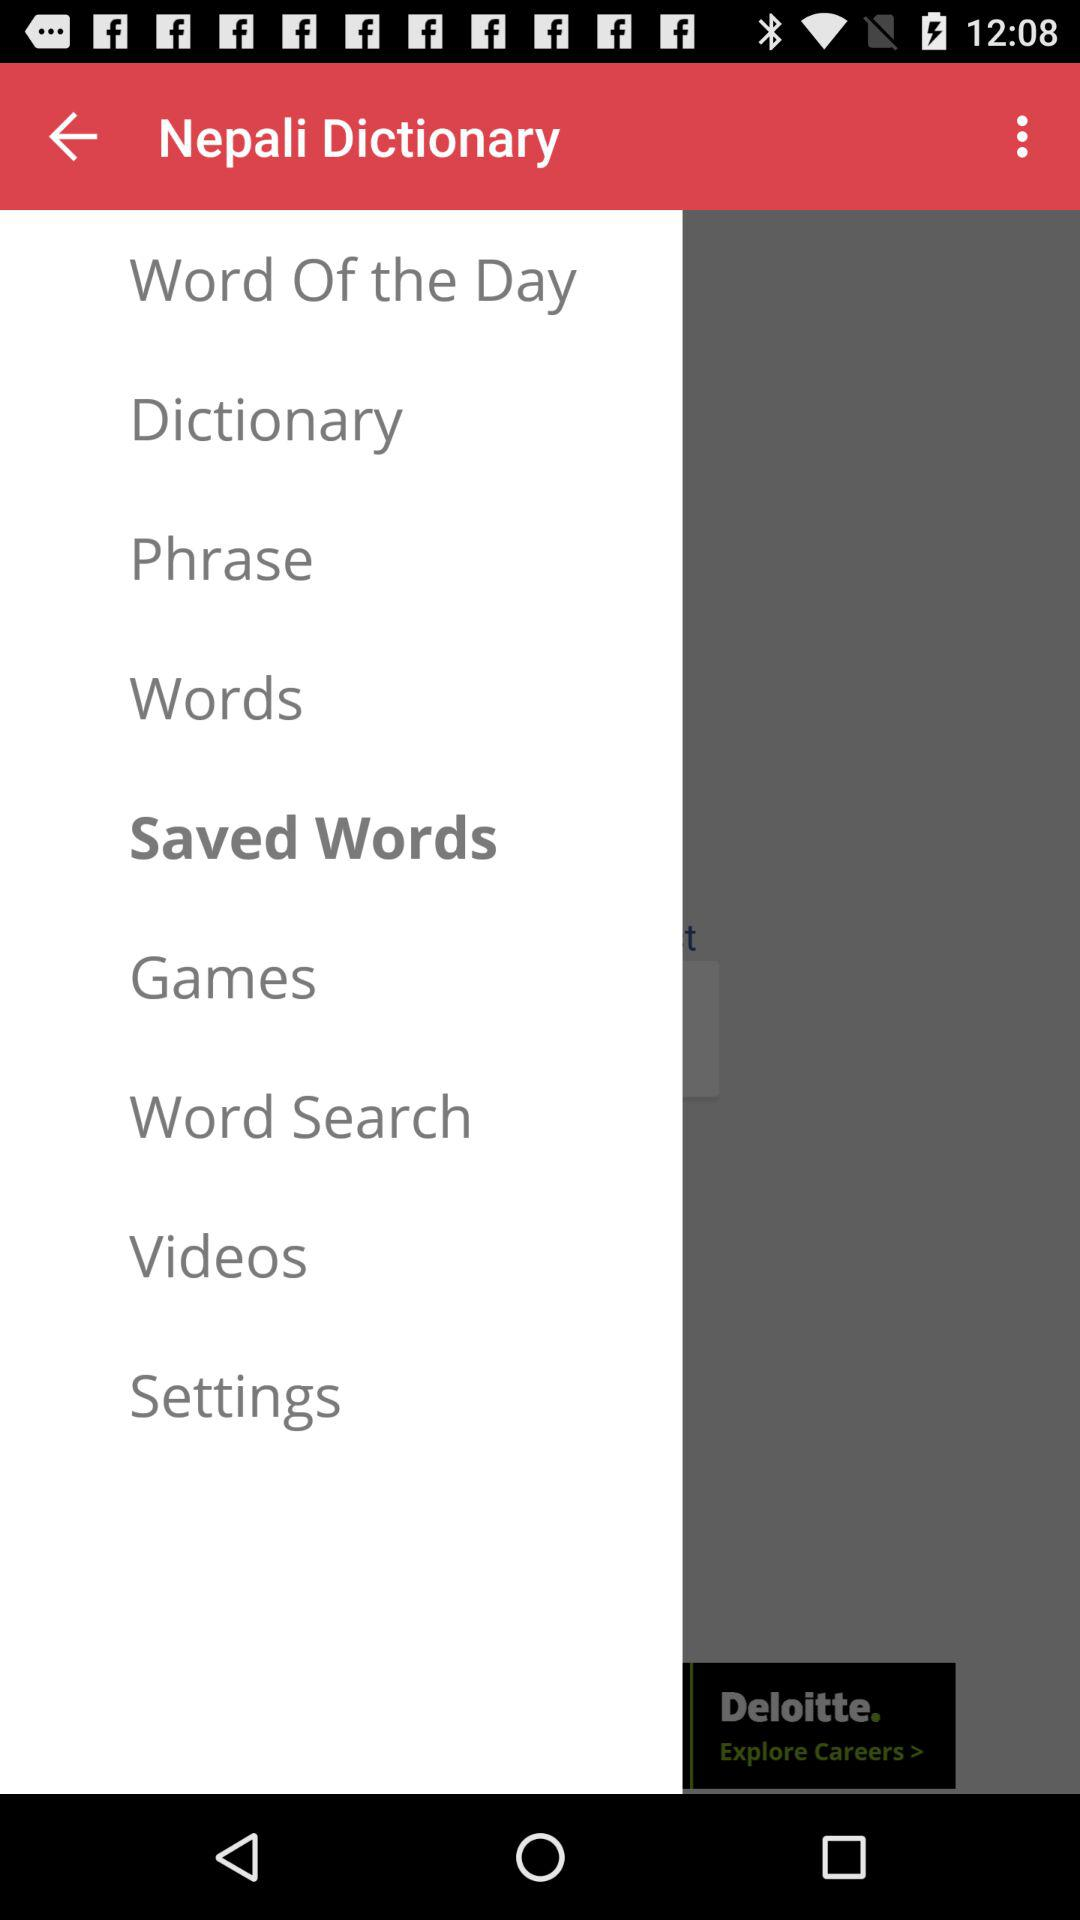What is the application name? The application name is "Nepali Dictionary". 